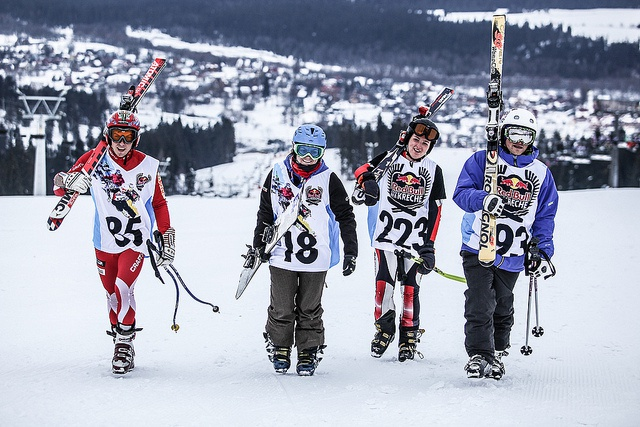Describe the objects in this image and their specific colors. I can see people in darkblue, black, lavender, navy, and gray tones, people in darkblue, black, lavender, gray, and darkgray tones, people in darkblue, lavender, black, brown, and darkgray tones, people in darkblue, black, lavender, gray, and darkgray tones, and skis in darkblue, lightgray, black, gray, and darkgray tones in this image. 